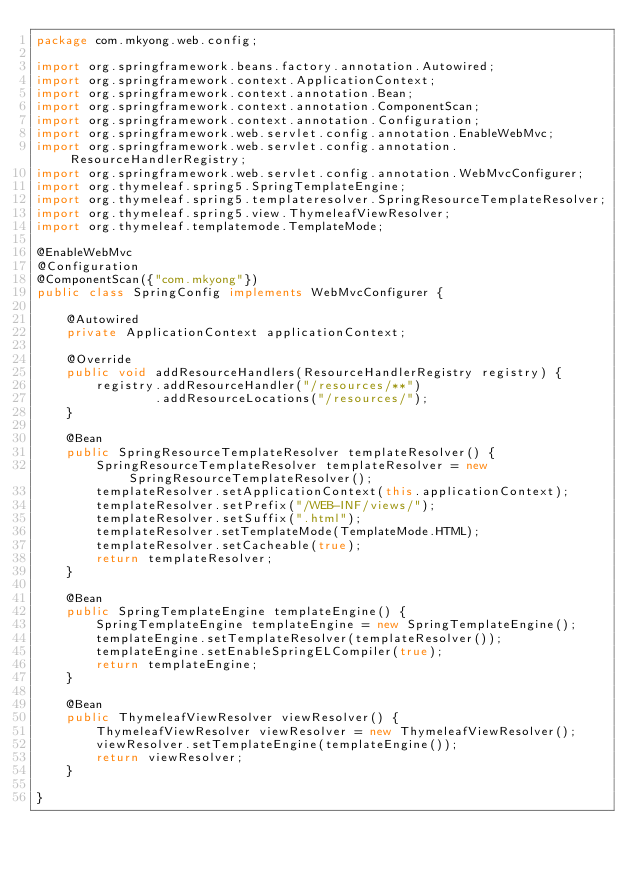Convert code to text. <code><loc_0><loc_0><loc_500><loc_500><_Java_>package com.mkyong.web.config;

import org.springframework.beans.factory.annotation.Autowired;
import org.springframework.context.ApplicationContext;
import org.springframework.context.annotation.Bean;
import org.springframework.context.annotation.ComponentScan;
import org.springframework.context.annotation.Configuration;
import org.springframework.web.servlet.config.annotation.EnableWebMvc;
import org.springframework.web.servlet.config.annotation.ResourceHandlerRegistry;
import org.springframework.web.servlet.config.annotation.WebMvcConfigurer;
import org.thymeleaf.spring5.SpringTemplateEngine;
import org.thymeleaf.spring5.templateresolver.SpringResourceTemplateResolver;
import org.thymeleaf.spring5.view.ThymeleafViewResolver;
import org.thymeleaf.templatemode.TemplateMode;

@EnableWebMvc
@Configuration
@ComponentScan({"com.mkyong"})
public class SpringConfig implements WebMvcConfigurer {

    @Autowired
    private ApplicationContext applicationContext;

    @Override
    public void addResourceHandlers(ResourceHandlerRegistry registry) {
        registry.addResourceHandler("/resources/**")
                .addResourceLocations("/resources/");
    }

    @Bean
    public SpringResourceTemplateResolver templateResolver() {
        SpringResourceTemplateResolver templateResolver = new SpringResourceTemplateResolver();
        templateResolver.setApplicationContext(this.applicationContext);
        templateResolver.setPrefix("/WEB-INF/views/");
        templateResolver.setSuffix(".html");
        templateResolver.setTemplateMode(TemplateMode.HTML);
        templateResolver.setCacheable(true);
        return templateResolver;
    }

    @Bean
    public SpringTemplateEngine templateEngine() {
        SpringTemplateEngine templateEngine = new SpringTemplateEngine();
        templateEngine.setTemplateResolver(templateResolver());
        templateEngine.setEnableSpringELCompiler(true);
        return templateEngine;
    }

    @Bean
    public ThymeleafViewResolver viewResolver() {
        ThymeleafViewResolver viewResolver = new ThymeleafViewResolver();
        viewResolver.setTemplateEngine(templateEngine());
        return viewResolver;
    }

}
</code> 